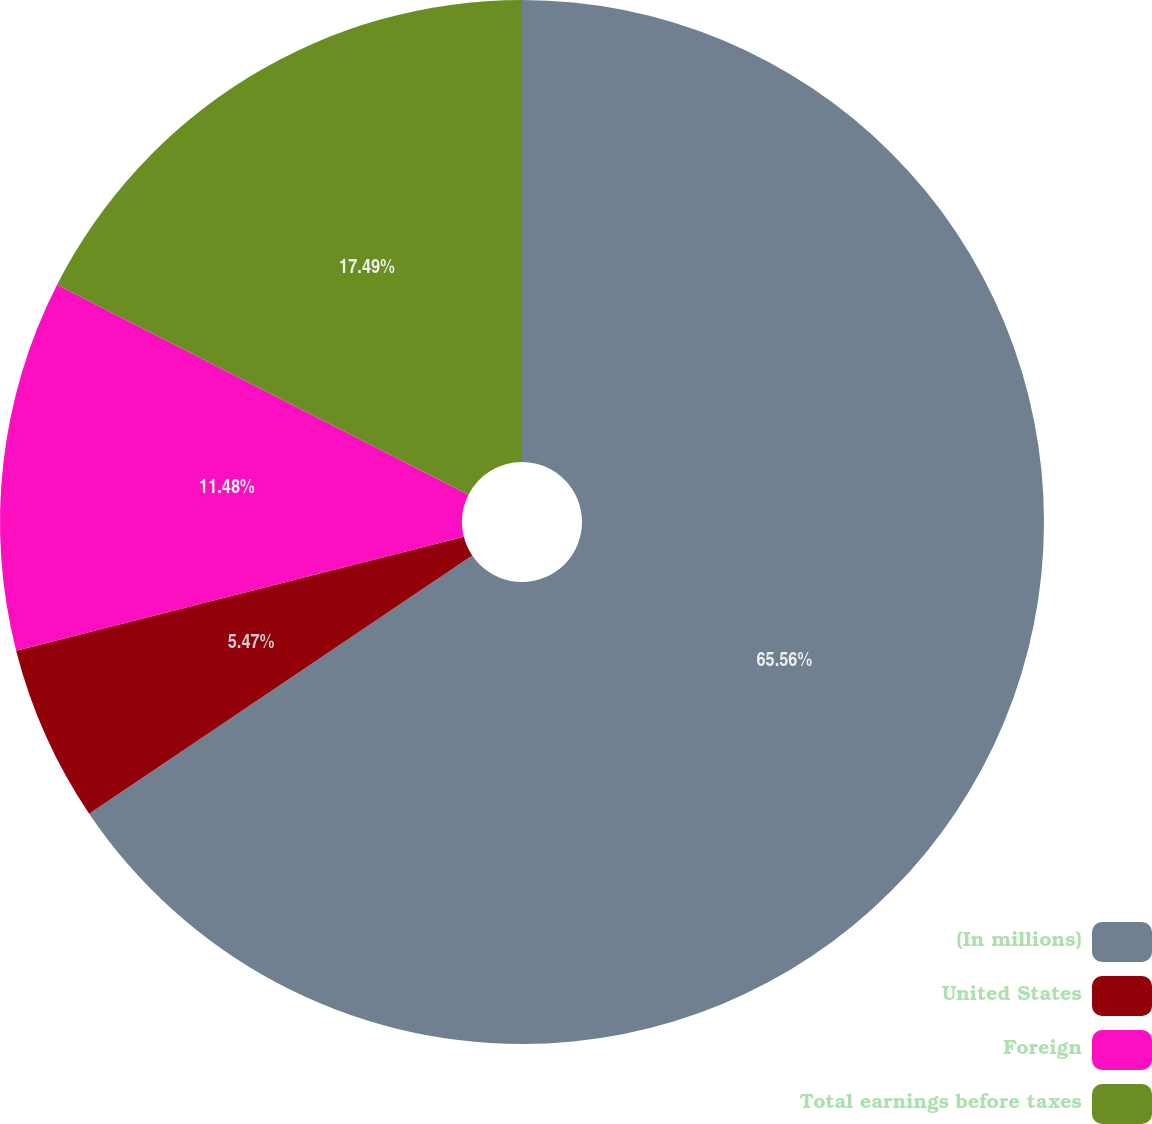Convert chart to OTSL. <chart><loc_0><loc_0><loc_500><loc_500><pie_chart><fcel>(In millions)<fcel>United States<fcel>Foreign<fcel>Total earnings before taxes<nl><fcel>65.56%<fcel>5.47%<fcel>11.48%<fcel>17.49%<nl></chart> 